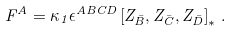<formula> <loc_0><loc_0><loc_500><loc_500>F ^ { A } = \kappa _ { 1 } \epsilon ^ { A B C D } \left [ Z _ { \bar { B } } , Z _ { \bar { C } } , Z _ { \bar { D } } \right ] _ { * } \, .</formula> 